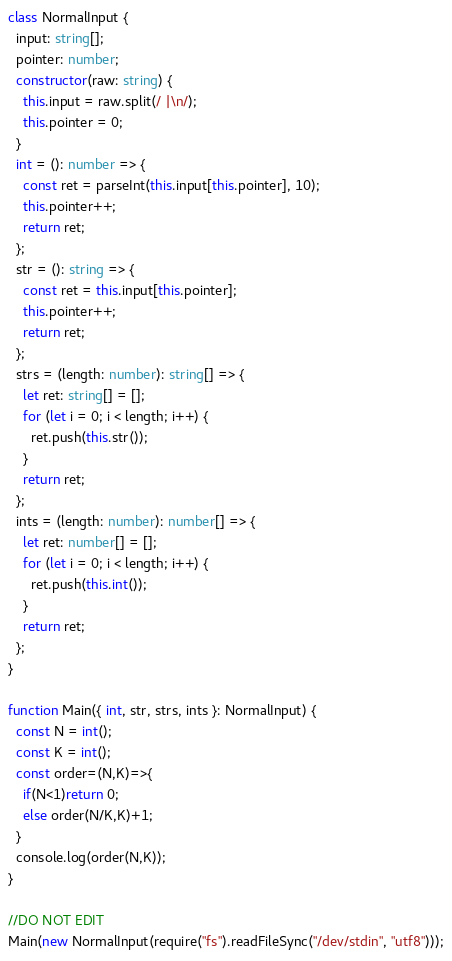<code> <loc_0><loc_0><loc_500><loc_500><_TypeScript_>class NormalInput {
  input: string[];
  pointer: number;
  constructor(raw: string) {
    this.input = raw.split(/ |\n/);
    this.pointer = 0;
  }
  int = (): number => {
    const ret = parseInt(this.input[this.pointer], 10);
    this.pointer++;
    return ret;
  };
  str = (): string => {
    const ret = this.input[this.pointer];
    this.pointer++;
    return ret;
  };
  strs = (length: number): string[] => {
    let ret: string[] = [];
    for (let i = 0; i < length; i++) {
      ret.push(this.str());
    }
    return ret;
  };
  ints = (length: number): number[] => {
    let ret: number[] = [];
    for (let i = 0; i < length; i++) {
      ret.push(this.int());
    }
    return ret;
  };
}

function Main({ int, str, strs, ints }: NormalInput) {
  const N = int();
  const K = int();
  const order=(N,K)=>{
    if(N<1)return 0;
    else order(N/K,K)+1; 
  }
  console.log(order(N,K));
}

//DO NOT EDIT
Main(new NormalInput(require("fs").readFileSync("/dev/stdin", "utf8")));
</code> 